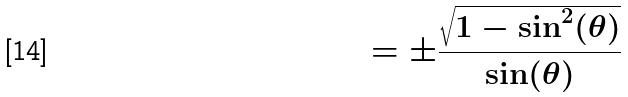<formula> <loc_0><loc_0><loc_500><loc_500>= \pm \frac { \sqrt { 1 - \sin ^ { 2 } ( \theta ) } } { \sin ( \theta ) }</formula> 